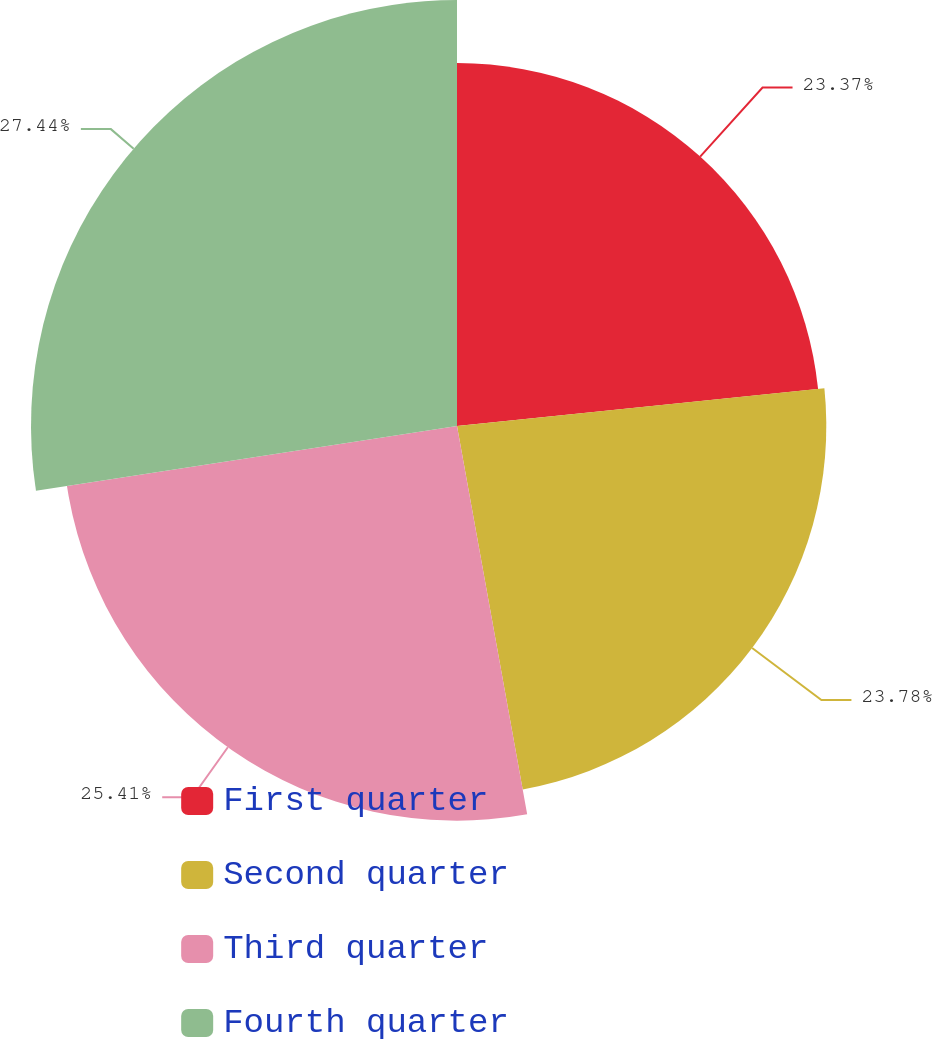Convert chart. <chart><loc_0><loc_0><loc_500><loc_500><pie_chart><fcel>First quarter<fcel>Second quarter<fcel>Third quarter<fcel>Fourth quarter<nl><fcel>23.37%<fcel>23.78%<fcel>25.41%<fcel>27.43%<nl></chart> 